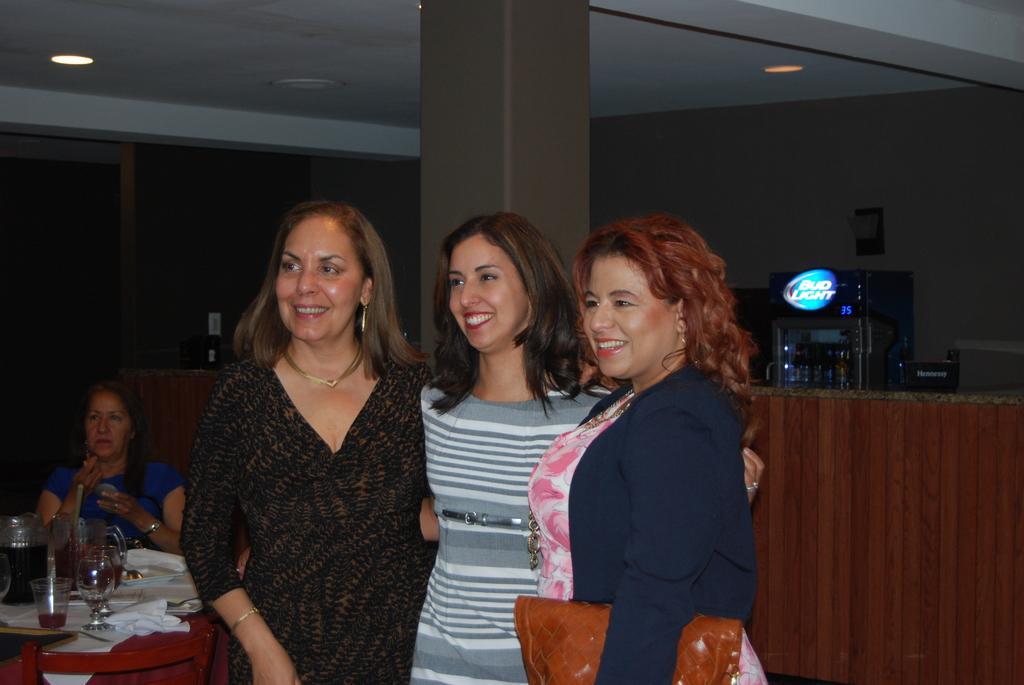How would you summarize this image in a sentence or two? In this image in front there are three people wearing a smile on their faces. Behind them there is a pillar. Beside them there is a table. On top of it there are glasses, clothes. There is a person sitting on the chair. In the background of the image there is a wall. There is a fridge with some objects in it. On top of the image there are lights. 